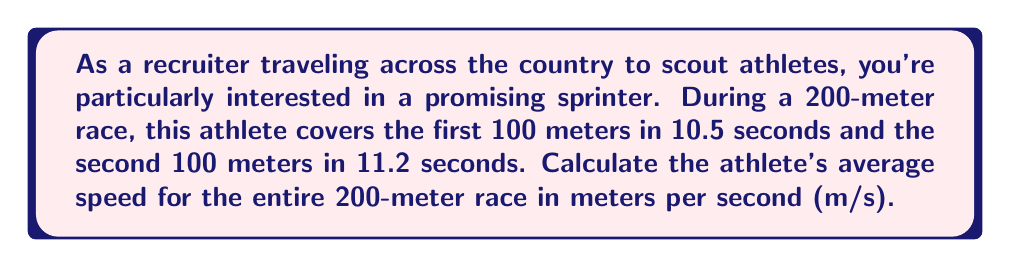Give your solution to this math problem. To solve this problem, let's break it down into steps:

1) First, we need to find the total time for the race:
   $$\text{Total time} = 10.5\text{ s} + 11.2\text{ s} = 21.7\text{ s}$$

2) We know the total distance is 200 meters.

3) The formula for average speed is:
   $$\text{Average Speed} = \frac{\text{Total Distance}}{\text{Total Time}}$$

4) Substituting our values:
   $$\text{Average Speed} = \frac{200\text{ m}}{21.7\text{ s}}$$

5) Performing the division:
   $$\text{Average Speed} = 9.22\text{ m/s}$$

6) Rounding to two decimal places:
   $$\text{Average Speed} \approx 9.22\text{ m/s}$$

This method gives us the average speed over the entire race, taking into account the different speeds in the first and second halves of the race.
Answer: $9.22\text{ m/s}$ 